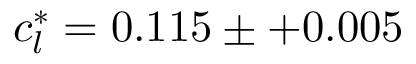Convert formula to latex. <formula><loc_0><loc_0><loc_500><loc_500>c _ { l } ^ { * } = 0 . 1 1 5 \pm + 0 . 0 0 5</formula> 